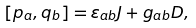Convert formula to latex. <formula><loc_0><loc_0><loc_500><loc_500>[ p _ { a } , q _ { b } ] = \varepsilon _ { a b } J + g _ { a b } D ,</formula> 